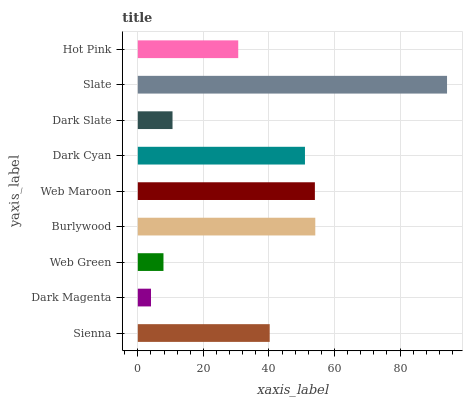Is Dark Magenta the minimum?
Answer yes or no. Yes. Is Slate the maximum?
Answer yes or no. Yes. Is Web Green the minimum?
Answer yes or no. No. Is Web Green the maximum?
Answer yes or no. No. Is Web Green greater than Dark Magenta?
Answer yes or no. Yes. Is Dark Magenta less than Web Green?
Answer yes or no. Yes. Is Dark Magenta greater than Web Green?
Answer yes or no. No. Is Web Green less than Dark Magenta?
Answer yes or no. No. Is Sienna the high median?
Answer yes or no. Yes. Is Sienna the low median?
Answer yes or no. Yes. Is Burlywood the high median?
Answer yes or no. No. Is Slate the low median?
Answer yes or no. No. 